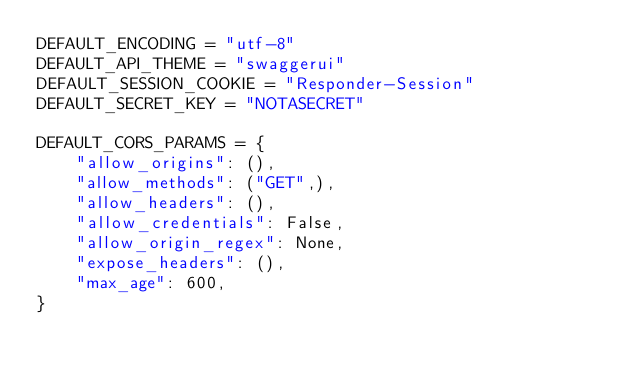<code> <loc_0><loc_0><loc_500><loc_500><_Python_>DEFAULT_ENCODING = "utf-8"
DEFAULT_API_THEME = "swaggerui"
DEFAULT_SESSION_COOKIE = "Responder-Session"
DEFAULT_SECRET_KEY = "NOTASECRET"

DEFAULT_CORS_PARAMS = {
	"allow_origins": (),
	"allow_methods": ("GET",),
	"allow_headers": (),
	"allow_credentials": False,
	"allow_origin_regex": None,
	"expose_headers": (),
	"max_age": 600,
}
</code> 